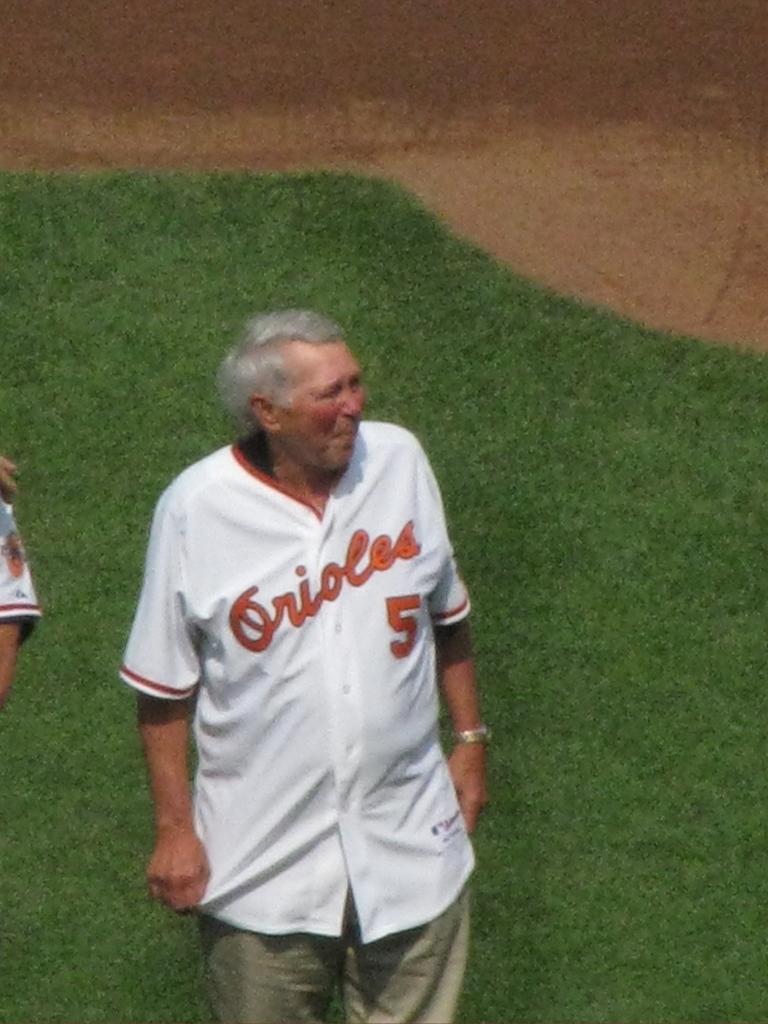What team did he once play for?
Provide a short and direct response. Orioles. 